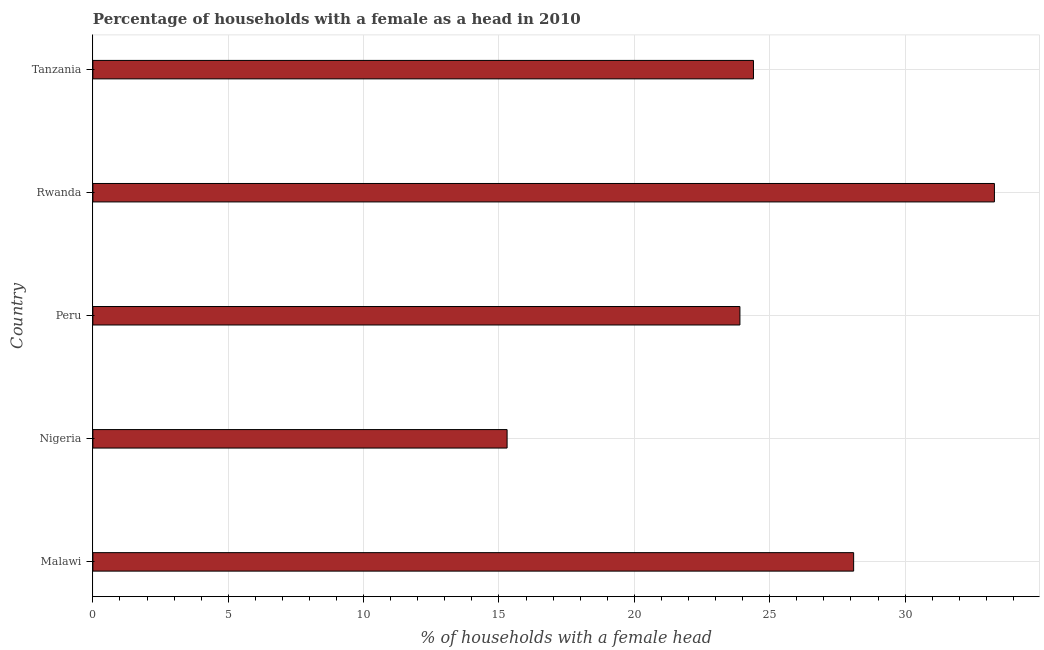Does the graph contain grids?
Your response must be concise. Yes. What is the title of the graph?
Offer a terse response. Percentage of households with a female as a head in 2010. What is the label or title of the X-axis?
Provide a short and direct response. % of households with a female head. What is the number of female supervised households in Peru?
Provide a succinct answer. 23.9. Across all countries, what is the maximum number of female supervised households?
Offer a terse response. 33.3. Across all countries, what is the minimum number of female supervised households?
Make the answer very short. 15.3. In which country was the number of female supervised households maximum?
Your response must be concise. Rwanda. In which country was the number of female supervised households minimum?
Keep it short and to the point. Nigeria. What is the sum of the number of female supervised households?
Make the answer very short. 125. What is the difference between the number of female supervised households in Malawi and Rwanda?
Ensure brevity in your answer.  -5.2. What is the average number of female supervised households per country?
Your response must be concise. 25. What is the median number of female supervised households?
Provide a short and direct response. 24.4. What is the ratio of the number of female supervised households in Malawi to that in Peru?
Ensure brevity in your answer.  1.18. Is the number of female supervised households in Peru less than that in Rwanda?
Offer a very short reply. Yes. What is the difference between the highest and the second highest number of female supervised households?
Provide a succinct answer. 5.2. Is the sum of the number of female supervised households in Malawi and Peru greater than the maximum number of female supervised households across all countries?
Provide a succinct answer. Yes. What is the difference between the highest and the lowest number of female supervised households?
Offer a terse response. 18. In how many countries, is the number of female supervised households greater than the average number of female supervised households taken over all countries?
Give a very brief answer. 2. What is the difference between two consecutive major ticks on the X-axis?
Give a very brief answer. 5. Are the values on the major ticks of X-axis written in scientific E-notation?
Offer a terse response. No. What is the % of households with a female head in Malawi?
Keep it short and to the point. 28.1. What is the % of households with a female head in Nigeria?
Provide a short and direct response. 15.3. What is the % of households with a female head in Peru?
Make the answer very short. 23.9. What is the % of households with a female head in Rwanda?
Your answer should be very brief. 33.3. What is the % of households with a female head in Tanzania?
Make the answer very short. 24.4. What is the difference between the % of households with a female head in Malawi and Peru?
Provide a short and direct response. 4.2. What is the difference between the % of households with a female head in Malawi and Rwanda?
Keep it short and to the point. -5.2. What is the difference between the % of households with a female head in Nigeria and Peru?
Your answer should be compact. -8.6. What is the difference between the % of households with a female head in Nigeria and Tanzania?
Ensure brevity in your answer.  -9.1. What is the difference between the % of households with a female head in Peru and Rwanda?
Your answer should be compact. -9.4. What is the difference between the % of households with a female head in Peru and Tanzania?
Provide a succinct answer. -0.5. What is the ratio of the % of households with a female head in Malawi to that in Nigeria?
Your answer should be very brief. 1.84. What is the ratio of the % of households with a female head in Malawi to that in Peru?
Keep it short and to the point. 1.18. What is the ratio of the % of households with a female head in Malawi to that in Rwanda?
Keep it short and to the point. 0.84. What is the ratio of the % of households with a female head in Malawi to that in Tanzania?
Give a very brief answer. 1.15. What is the ratio of the % of households with a female head in Nigeria to that in Peru?
Your answer should be very brief. 0.64. What is the ratio of the % of households with a female head in Nigeria to that in Rwanda?
Provide a succinct answer. 0.46. What is the ratio of the % of households with a female head in Nigeria to that in Tanzania?
Provide a succinct answer. 0.63. What is the ratio of the % of households with a female head in Peru to that in Rwanda?
Ensure brevity in your answer.  0.72. What is the ratio of the % of households with a female head in Peru to that in Tanzania?
Ensure brevity in your answer.  0.98. What is the ratio of the % of households with a female head in Rwanda to that in Tanzania?
Your answer should be very brief. 1.36. 